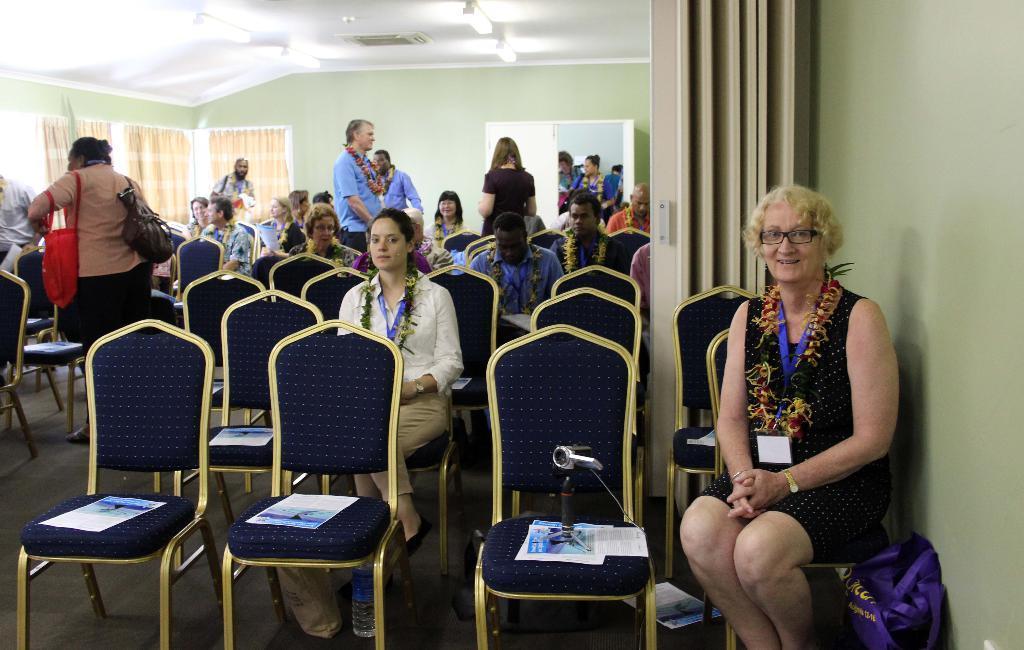Describe this image in one or two sentences. At the top we see ceiling, lights and central AC. On the background we can see wall, windows and curtains. Here we can see few persons standing and few are sitting on chairs and on the chairs we can see papers and a camera. At the right side of the picture we can see a woman wearing spectacles and id card. Beside to her there is a bag. 